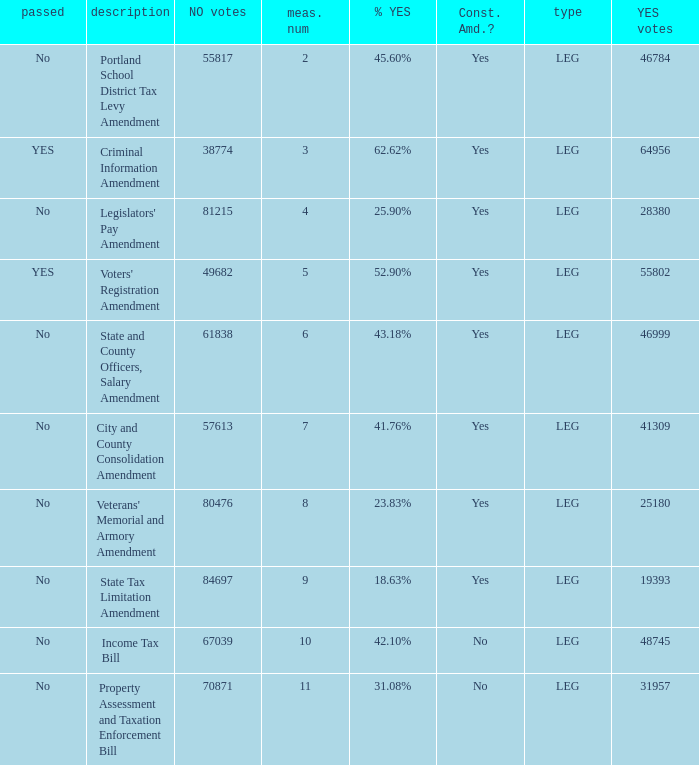Who had 41.76% yes votes City and County Consolidation Amendment. 